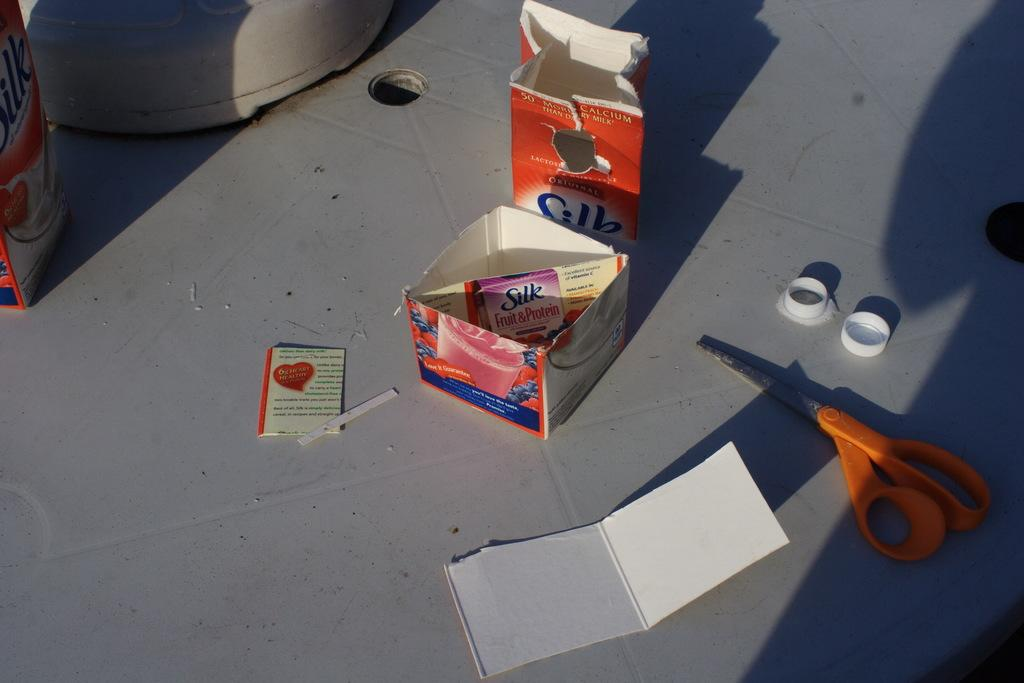Provide a one-sentence caption for the provided image. Someone has cut up the Silk soy milk carton into a small box with diagonal divider in the middle. 